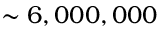<formula> <loc_0><loc_0><loc_500><loc_500>\sim 6 , 0 0 0 , 0 0 0</formula> 